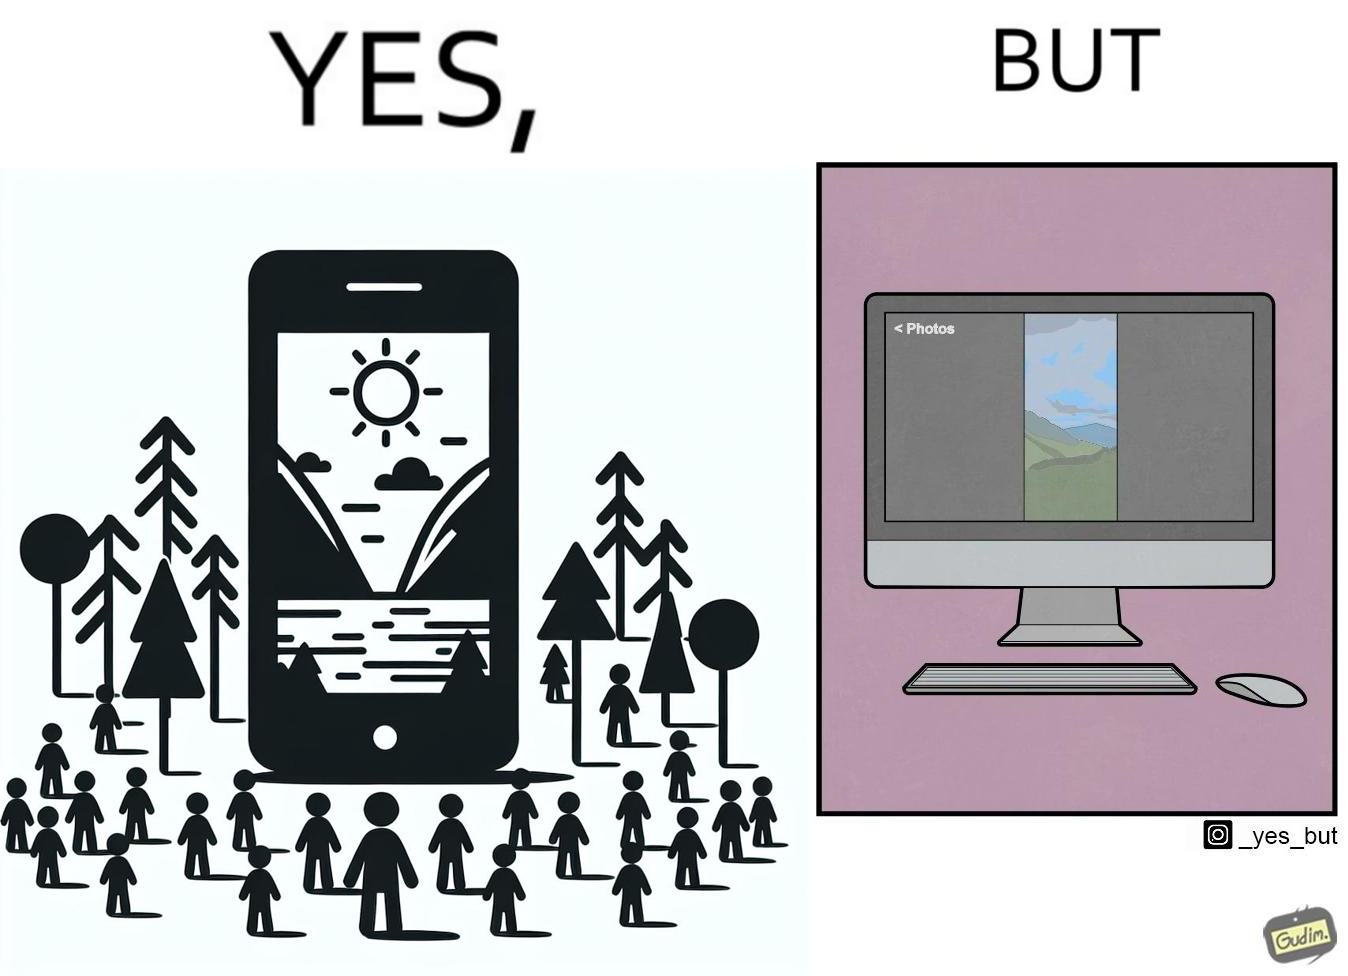Is there satirical content in this image? Yes, this image is satirical. 